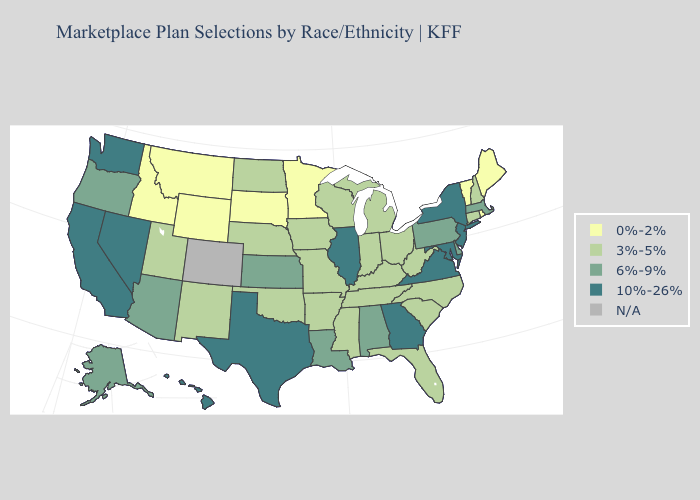What is the value of Rhode Island?
Give a very brief answer. 0%-2%. Name the states that have a value in the range 6%-9%?
Give a very brief answer. Alabama, Alaska, Arizona, Delaware, Kansas, Louisiana, Massachusetts, Oregon, Pennsylvania. Name the states that have a value in the range 10%-26%?
Give a very brief answer. California, Georgia, Hawaii, Illinois, Maryland, Nevada, New Jersey, New York, Texas, Virginia, Washington. Name the states that have a value in the range 3%-5%?
Be succinct. Arkansas, Connecticut, Florida, Indiana, Iowa, Kentucky, Michigan, Mississippi, Missouri, Nebraska, New Hampshire, New Mexico, North Carolina, North Dakota, Ohio, Oklahoma, South Carolina, Tennessee, Utah, West Virginia, Wisconsin. What is the lowest value in the South?
Give a very brief answer. 3%-5%. Which states have the highest value in the USA?
Short answer required. California, Georgia, Hawaii, Illinois, Maryland, Nevada, New Jersey, New York, Texas, Virginia, Washington. Name the states that have a value in the range 10%-26%?
Concise answer only. California, Georgia, Hawaii, Illinois, Maryland, Nevada, New Jersey, New York, Texas, Virginia, Washington. What is the lowest value in the USA?
Be succinct. 0%-2%. Name the states that have a value in the range 10%-26%?
Write a very short answer. California, Georgia, Hawaii, Illinois, Maryland, Nevada, New Jersey, New York, Texas, Virginia, Washington. What is the lowest value in the USA?
Quick response, please. 0%-2%. Does the first symbol in the legend represent the smallest category?
Answer briefly. Yes. Name the states that have a value in the range 10%-26%?
Keep it brief. California, Georgia, Hawaii, Illinois, Maryland, Nevada, New Jersey, New York, Texas, Virginia, Washington. What is the highest value in the South ?
Short answer required. 10%-26%. What is the highest value in states that border New Jersey?
Answer briefly. 10%-26%. Name the states that have a value in the range 6%-9%?
Give a very brief answer. Alabama, Alaska, Arizona, Delaware, Kansas, Louisiana, Massachusetts, Oregon, Pennsylvania. 